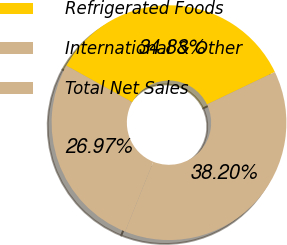<chart> <loc_0><loc_0><loc_500><loc_500><pie_chart><fcel>Refrigerated Foods<fcel>International & Other<fcel>Total Net Sales<nl><fcel>34.83%<fcel>26.97%<fcel>38.2%<nl></chart> 